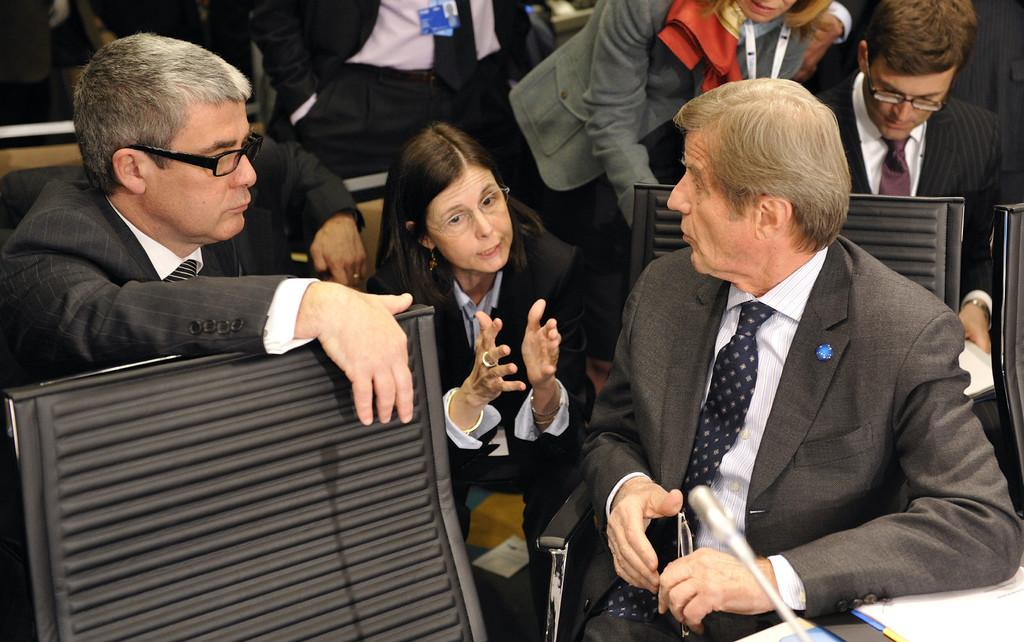Who or what can be seen in the image? There are people in the image. What objects are present that people might sit on? There are chairs in the image. What device is visible that might be used for amplifying sound? There is a microphone in the image. What type of decorations or signs are present at the bottom of the image? There are posters at the bottom of the image. What color is the pail that is being used by the people in the image? There is no pail present in the image. What route are the people taking in the image? The image does not show any route or path that the people are following. 